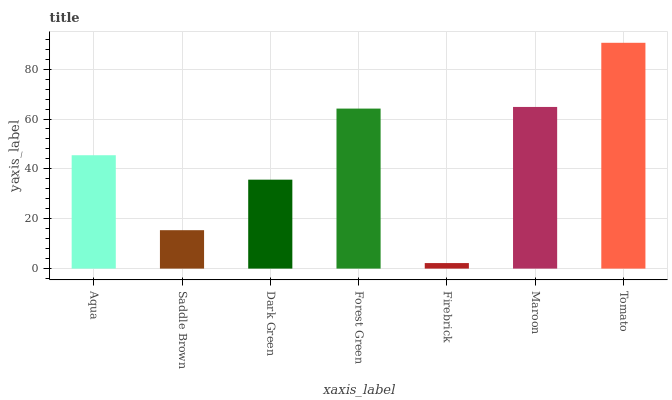Is Firebrick the minimum?
Answer yes or no. Yes. Is Tomato the maximum?
Answer yes or no. Yes. Is Saddle Brown the minimum?
Answer yes or no. No. Is Saddle Brown the maximum?
Answer yes or no. No. Is Aqua greater than Saddle Brown?
Answer yes or no. Yes. Is Saddle Brown less than Aqua?
Answer yes or no. Yes. Is Saddle Brown greater than Aqua?
Answer yes or no. No. Is Aqua less than Saddle Brown?
Answer yes or no. No. Is Aqua the high median?
Answer yes or no. Yes. Is Aqua the low median?
Answer yes or no. Yes. Is Saddle Brown the high median?
Answer yes or no. No. Is Saddle Brown the low median?
Answer yes or no. No. 